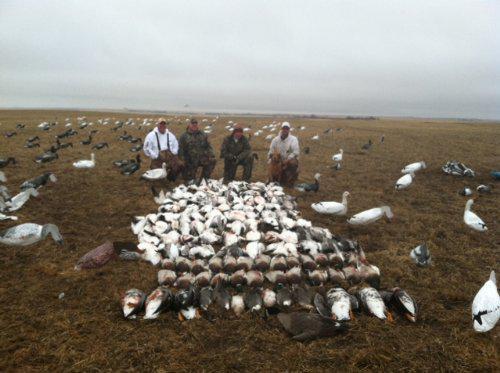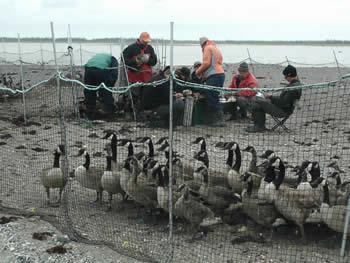The first image is the image on the left, the second image is the image on the right. Considering the images on both sides, is "A flock of birds are walking on a paved paint-striped road in one image." valid? Answer yes or no. No. The first image is the image on the left, the second image is the image on the right. Given the left and right images, does the statement "Neither of the images of geese contains a human standing on the ground." hold true? Answer yes or no. No. 